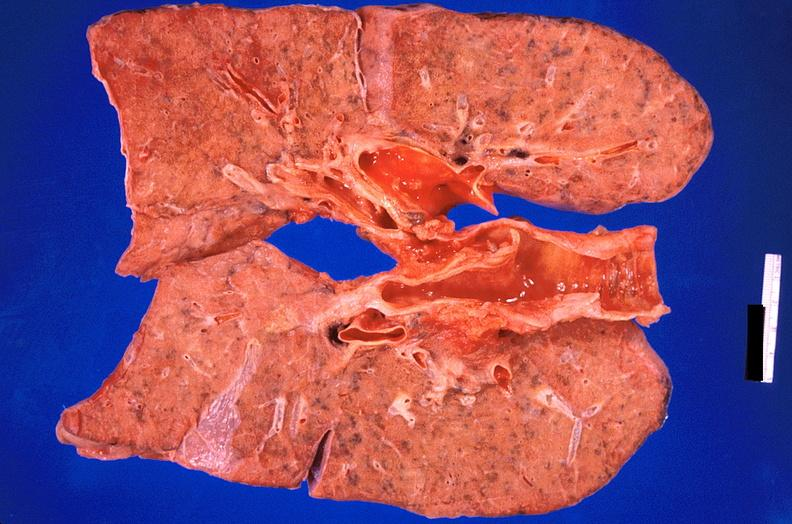s respiratory present?
Answer the question using a single word or phrase. Yes 